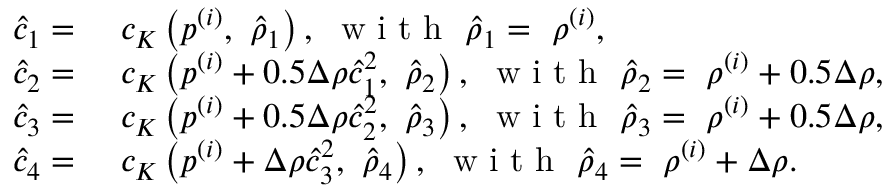<formula> <loc_0><loc_0><loc_500><loc_500>\begin{array} { r l } { \hat { c } _ { 1 } = } & c _ { K } \left ( p ^ { ( i ) } , \hat { \rho } _ { 1 } \right ) , w i t h \hat { \rho } _ { 1 } = \rho ^ { ( i ) } , } \\ { \hat { c } _ { 2 } = } & c _ { K } \left ( p ^ { ( i ) } + 0 . 5 \Delta \rho \hat { c } _ { 1 } ^ { 2 } , \hat { \rho } _ { 2 } \right ) , w i t h \hat { \rho } _ { 2 } = \rho ^ { ( i ) } + 0 . 5 \Delta \rho , } \\ { \hat { c } _ { 3 } = } & c _ { K } \left ( p ^ { ( i ) } + 0 . 5 \Delta \rho \hat { c } _ { 2 } ^ { 2 } , \hat { \rho } _ { 3 } \right ) , w i t h \hat { \rho } _ { 3 } = \rho ^ { ( i ) } + 0 . 5 \Delta \rho , } \\ { \hat { c } _ { 4 } = } & c _ { K } \left ( p ^ { ( i ) } + \Delta \rho \hat { c } _ { 3 } ^ { 2 } , \hat { \rho } _ { 4 } \right ) , w i t h \hat { \rho } _ { 4 } = \rho ^ { ( i ) } + \Delta \rho . } \end{array}</formula> 